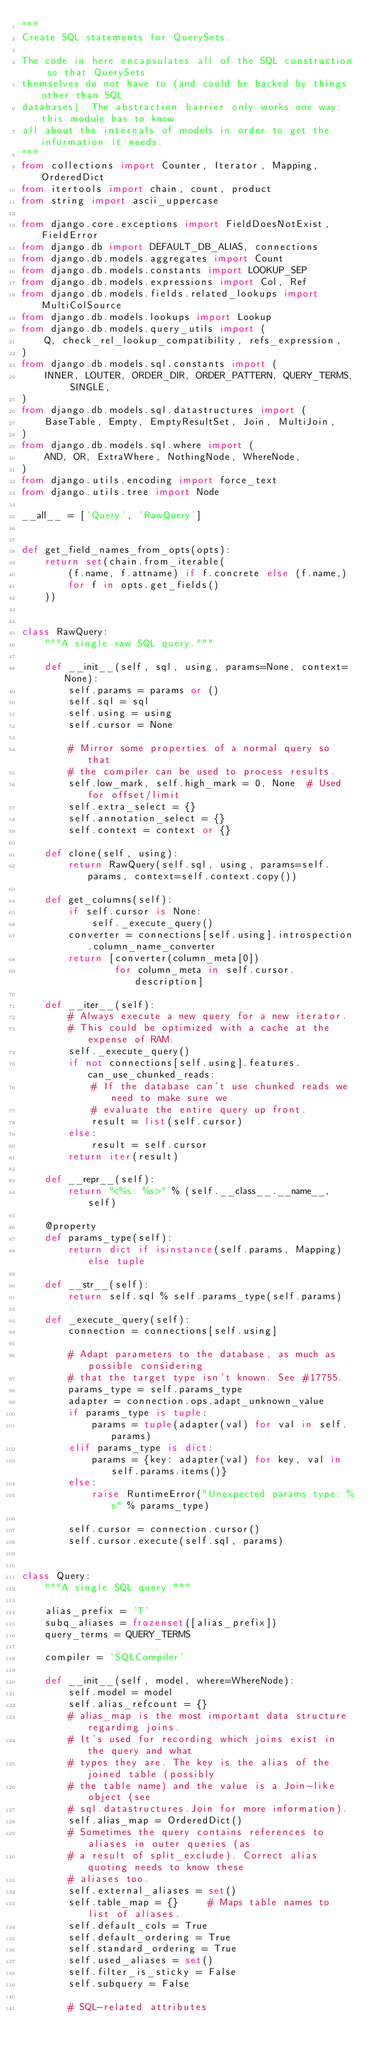Convert code to text. <code><loc_0><loc_0><loc_500><loc_500><_Python_>"""
Create SQL statements for QuerySets.

The code in here encapsulates all of the SQL construction so that QuerySets
themselves do not have to (and could be backed by things other than SQL
databases). The abstraction barrier only works one way: this module has to know
all about the internals of models in order to get the information it needs.
"""
from collections import Counter, Iterator, Mapping, OrderedDict
from itertools import chain, count, product
from string import ascii_uppercase

from django.core.exceptions import FieldDoesNotExist, FieldError
from django.db import DEFAULT_DB_ALIAS, connections
from django.db.models.aggregates import Count
from django.db.models.constants import LOOKUP_SEP
from django.db.models.expressions import Col, Ref
from django.db.models.fields.related_lookups import MultiColSource
from django.db.models.lookups import Lookup
from django.db.models.query_utils import (
    Q, check_rel_lookup_compatibility, refs_expression,
)
from django.db.models.sql.constants import (
    INNER, LOUTER, ORDER_DIR, ORDER_PATTERN, QUERY_TERMS, SINGLE,
)
from django.db.models.sql.datastructures import (
    BaseTable, Empty, EmptyResultSet, Join, MultiJoin,
)
from django.db.models.sql.where import (
    AND, OR, ExtraWhere, NothingNode, WhereNode,
)
from django.utils.encoding import force_text
from django.utils.tree import Node

__all__ = ['Query', 'RawQuery']


def get_field_names_from_opts(opts):
    return set(chain.from_iterable(
        (f.name, f.attname) if f.concrete else (f.name,)
        for f in opts.get_fields()
    ))


class RawQuery:
    """A single raw SQL query."""

    def __init__(self, sql, using, params=None, context=None):
        self.params = params or ()
        self.sql = sql
        self.using = using
        self.cursor = None

        # Mirror some properties of a normal query so that
        # the compiler can be used to process results.
        self.low_mark, self.high_mark = 0, None  # Used for offset/limit
        self.extra_select = {}
        self.annotation_select = {}
        self.context = context or {}

    def clone(self, using):
        return RawQuery(self.sql, using, params=self.params, context=self.context.copy())

    def get_columns(self):
        if self.cursor is None:
            self._execute_query()
        converter = connections[self.using].introspection.column_name_converter
        return [converter(column_meta[0])
                for column_meta in self.cursor.description]

    def __iter__(self):
        # Always execute a new query for a new iterator.
        # This could be optimized with a cache at the expense of RAM.
        self._execute_query()
        if not connections[self.using].features.can_use_chunked_reads:
            # If the database can't use chunked reads we need to make sure we
            # evaluate the entire query up front.
            result = list(self.cursor)
        else:
            result = self.cursor
        return iter(result)

    def __repr__(self):
        return "<%s: %s>" % (self.__class__.__name__, self)

    @property
    def params_type(self):
        return dict if isinstance(self.params, Mapping) else tuple

    def __str__(self):
        return self.sql % self.params_type(self.params)

    def _execute_query(self):
        connection = connections[self.using]

        # Adapt parameters to the database, as much as possible considering
        # that the target type isn't known. See #17755.
        params_type = self.params_type
        adapter = connection.ops.adapt_unknown_value
        if params_type is tuple:
            params = tuple(adapter(val) for val in self.params)
        elif params_type is dict:
            params = {key: adapter(val) for key, val in self.params.items()}
        else:
            raise RuntimeError("Unexpected params type: %s" % params_type)

        self.cursor = connection.cursor()
        self.cursor.execute(self.sql, params)


class Query:
    """A single SQL query."""

    alias_prefix = 'T'
    subq_aliases = frozenset([alias_prefix])
    query_terms = QUERY_TERMS

    compiler = 'SQLCompiler'

    def __init__(self, model, where=WhereNode):
        self.model = model
        self.alias_refcount = {}
        # alias_map is the most important data structure regarding joins.
        # It's used for recording which joins exist in the query and what
        # types they are. The key is the alias of the joined table (possibly
        # the table name) and the value is a Join-like object (see
        # sql.datastructures.Join for more information).
        self.alias_map = OrderedDict()
        # Sometimes the query contains references to aliases in outer queries (as
        # a result of split_exclude). Correct alias quoting needs to know these
        # aliases too.
        self.external_aliases = set()
        self.table_map = {}     # Maps table names to list of aliases.
        self.default_cols = True
        self.default_ordering = True
        self.standard_ordering = True
        self.used_aliases = set()
        self.filter_is_sticky = False
        self.subquery = False

        # SQL-related attributes</code> 